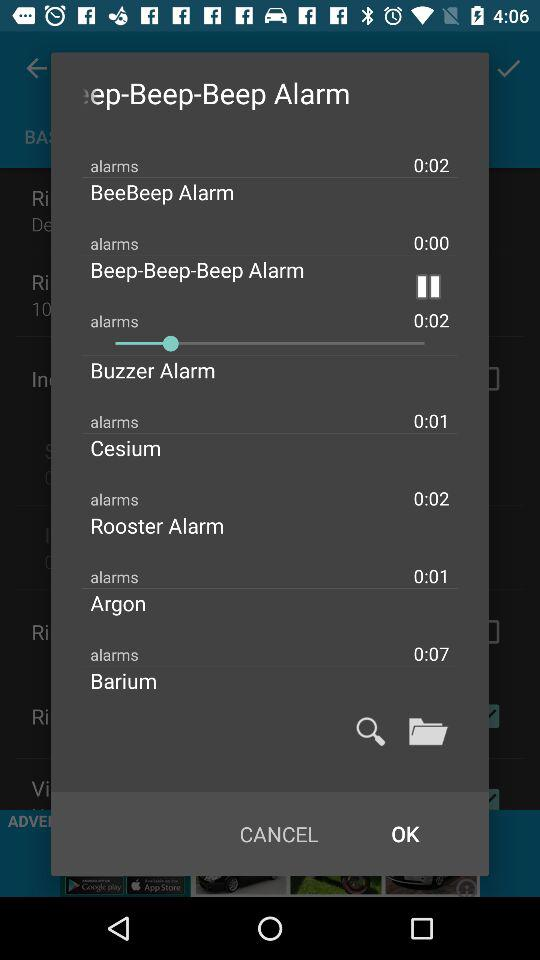What is the length of the Argon alarm? The length is 0:07. 